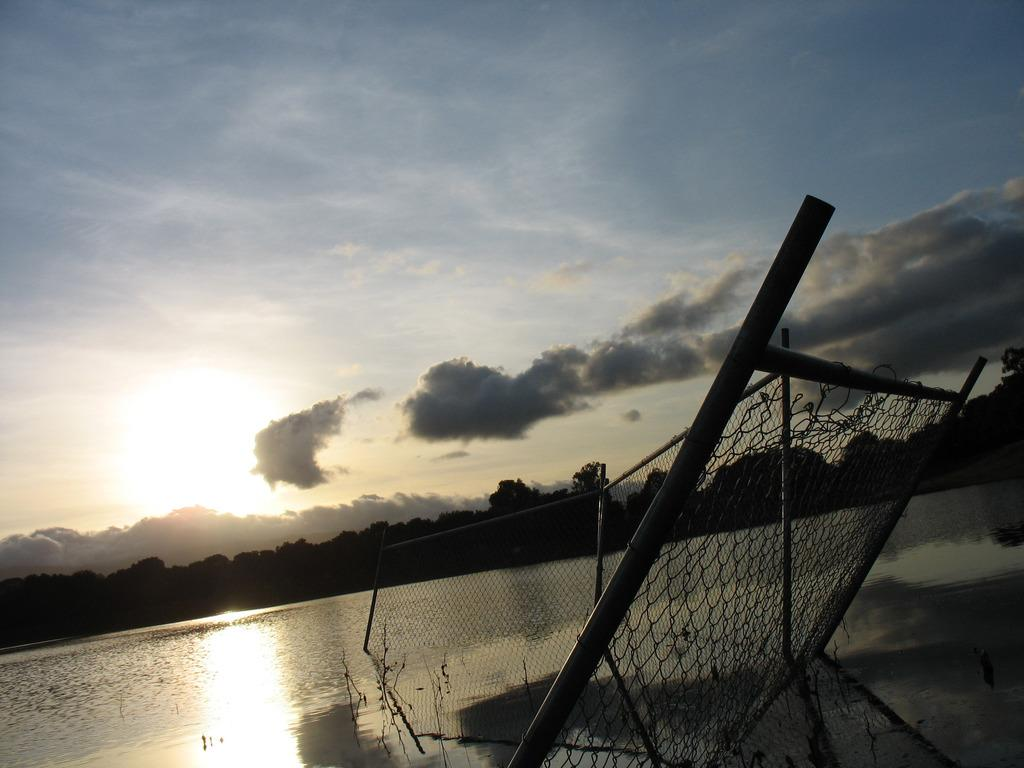What is the main structure visible in the water in the image? There is a fencing wall with poles in the water. What can be seen in the distance beyond the water? There are many trees visible in the distance. What is visible in the background of the image? The sky is visible in the background. What is the condition of the sky in the image? Clouds are present in the sky. How many feet are visible in the image? There are no feet visible in the image. What is the image trying to draw our attention to? The image does not have a specific subject or object that it is trying to draw attention to; it is a scene with multiple elements. 